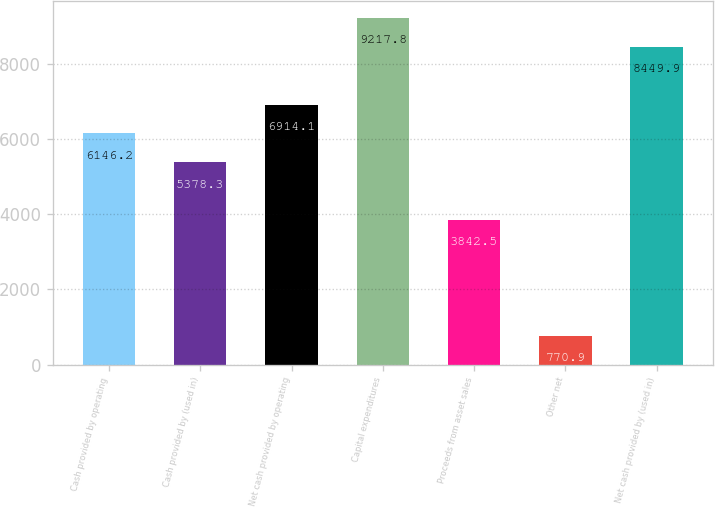<chart> <loc_0><loc_0><loc_500><loc_500><bar_chart><fcel>Cash provided by operating<fcel>Cash provided by (used in)<fcel>Net cash provided by operating<fcel>Capital expenditures<fcel>Proceeds from asset sales<fcel>Other net<fcel>Net cash provided by (used in)<nl><fcel>6146.2<fcel>5378.3<fcel>6914.1<fcel>9217.8<fcel>3842.5<fcel>770.9<fcel>8449.9<nl></chart> 